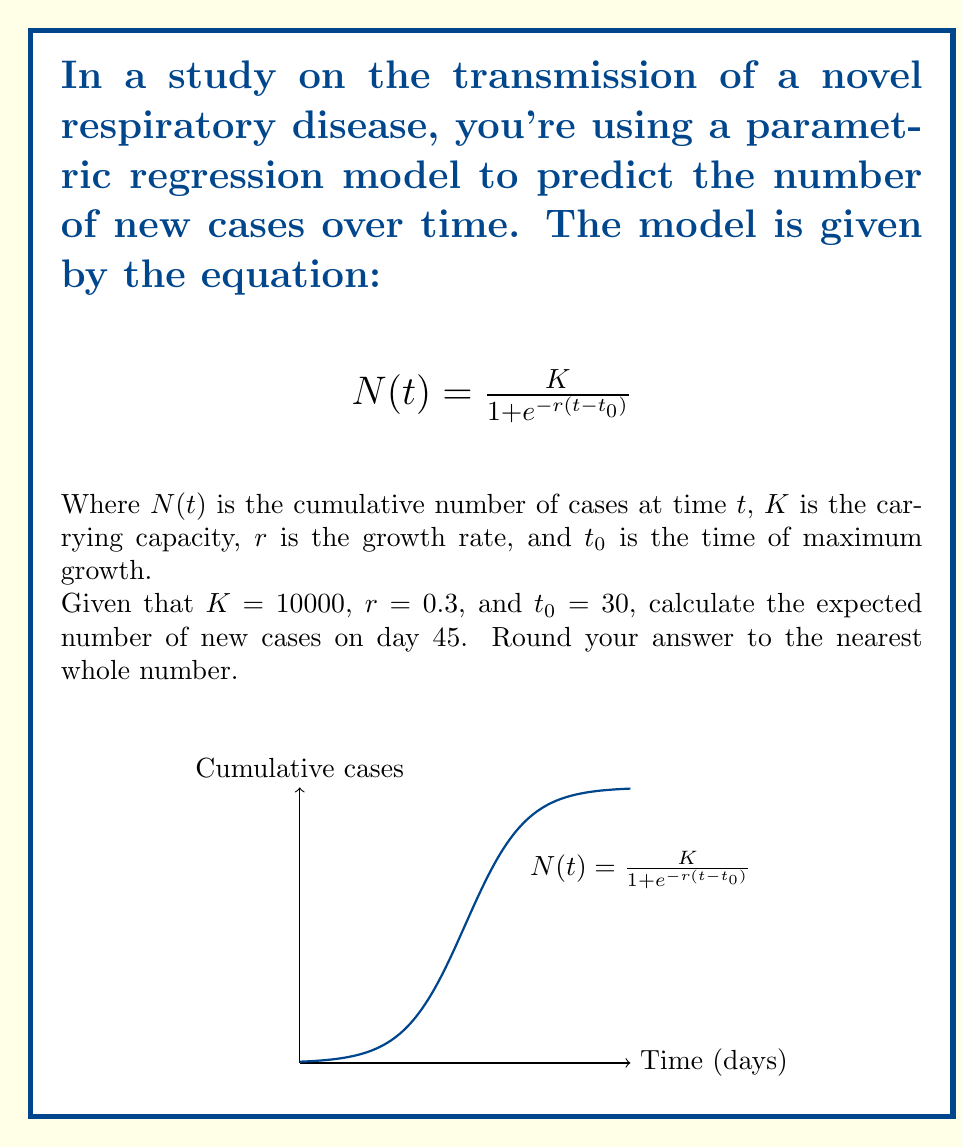Can you answer this question? To solve this problem, we'll follow these steps:

1) First, we need to calculate the cumulative number of cases at day 45 and day 44.

2) For day 45:
   $$N(45) = \frac{10000}{1 + e^{-0.3(45-30)}} = \frac{10000}{1 + e^{-0.3(15)}}$$

3) Let's calculate this:
   $$N(45) = \frac{10000}{1 + e^{-4.5}} = \frac{10000}{1 + 0.0111} = 9890.11$$

4) Now for day 44:
   $$N(44) = \frac{10000}{1 + e^{-0.3(44-30)}} = \frac{10000}{1 + e^{-0.3(14)}}$$

5) Calculating:
   $$N(44) = \frac{10000}{1 + e^{-4.2}} = \frac{10000}{1 + 0.0150} = 9852.22$$

6) The number of new cases on day 45 is the difference between these two values:
   $$\text{New cases} = N(45) - N(44) = 9890.11 - 9852.22 = 37.89$$

7) Rounding to the nearest whole number:
   $$\text{New cases} \approx 38$$
Answer: 38 